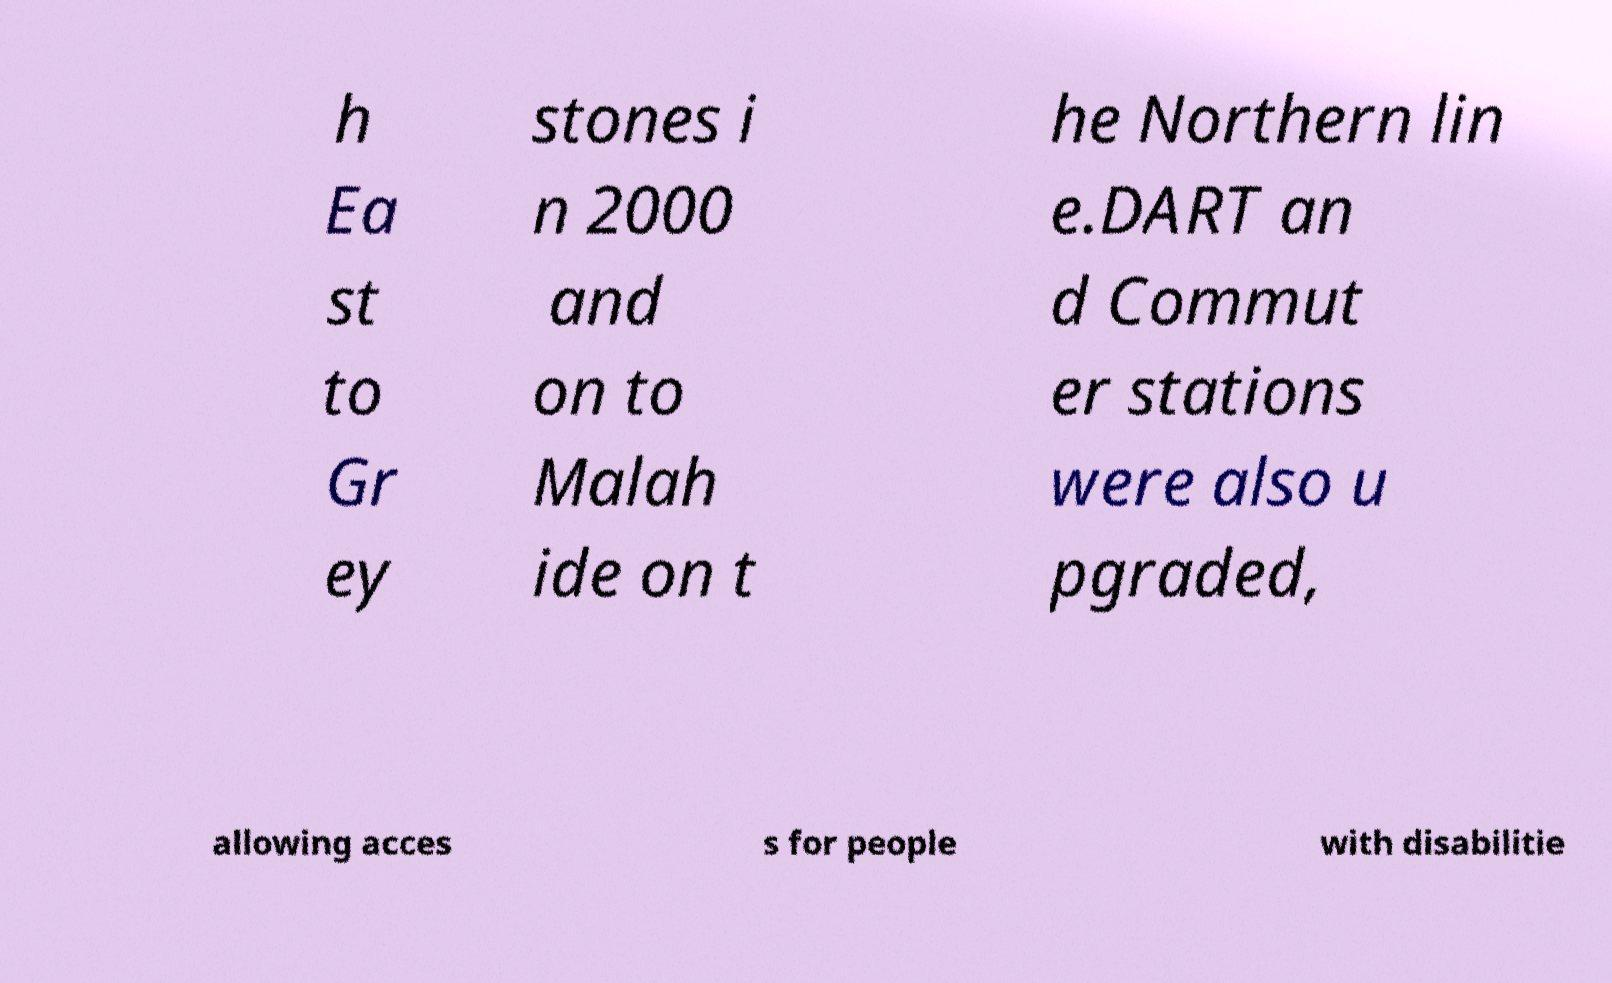What messages or text are displayed in this image? I need them in a readable, typed format. h Ea st to Gr ey stones i n 2000 and on to Malah ide on t he Northern lin e.DART an d Commut er stations were also u pgraded, allowing acces s for people with disabilitie 